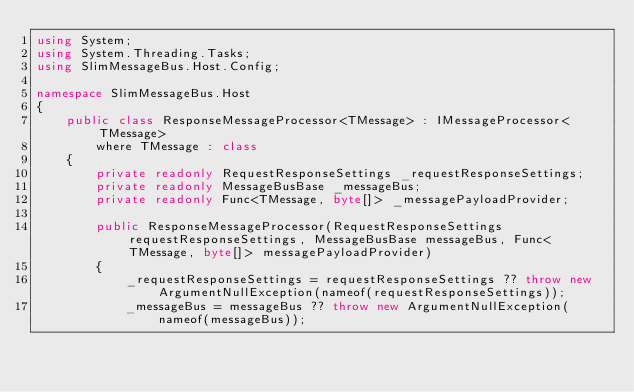Convert code to text. <code><loc_0><loc_0><loc_500><loc_500><_C#_>using System;
using System.Threading.Tasks;
using SlimMessageBus.Host.Config;

namespace SlimMessageBus.Host
{
    public class ResponseMessageProcessor<TMessage> : IMessageProcessor<TMessage> 
        where TMessage : class
    {
        private readonly RequestResponseSettings _requestResponseSettings;
        private readonly MessageBusBase _messageBus;
        private readonly Func<TMessage, byte[]> _messagePayloadProvider;

        public ResponseMessageProcessor(RequestResponseSettings requestResponseSettings, MessageBusBase messageBus, Func<TMessage, byte[]> messagePayloadProvider)
        {
            _requestResponseSettings = requestResponseSettings ?? throw new ArgumentNullException(nameof(requestResponseSettings));
            _messageBus = messageBus ?? throw new ArgumentNullException(nameof(messageBus));</code> 